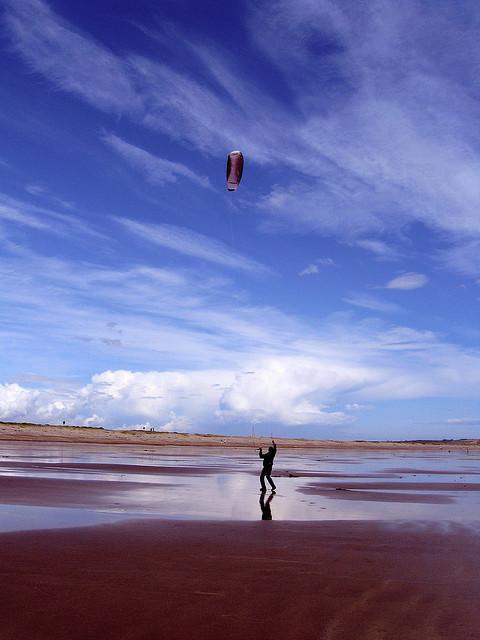How many people?
Give a very brief answer. 1. 